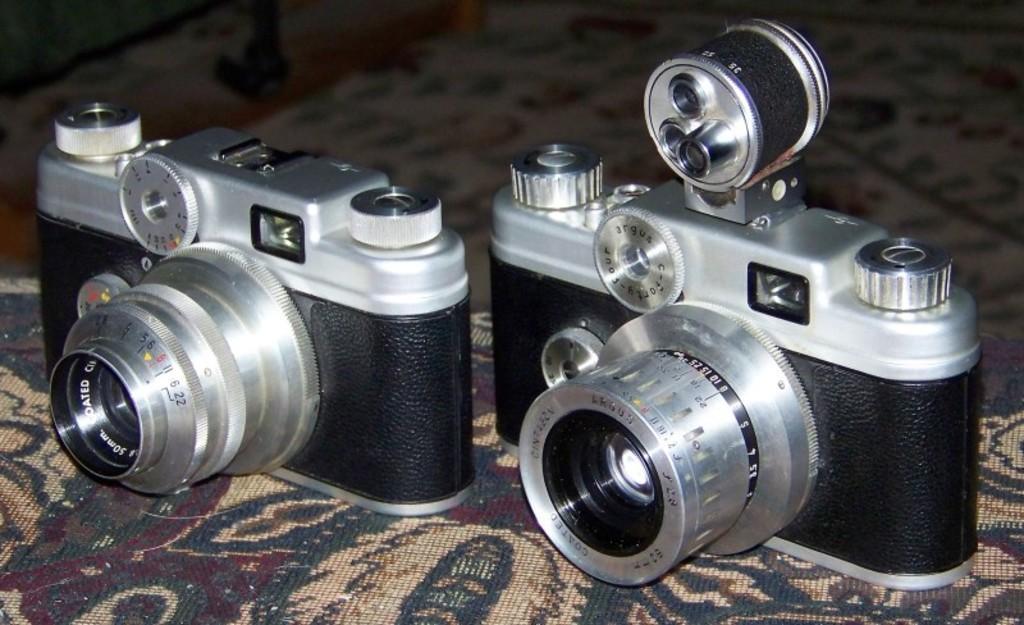Please provide a concise description of this image. In this picture I can see there are two cameras placed on a carpet and it has some hens and buttons. 